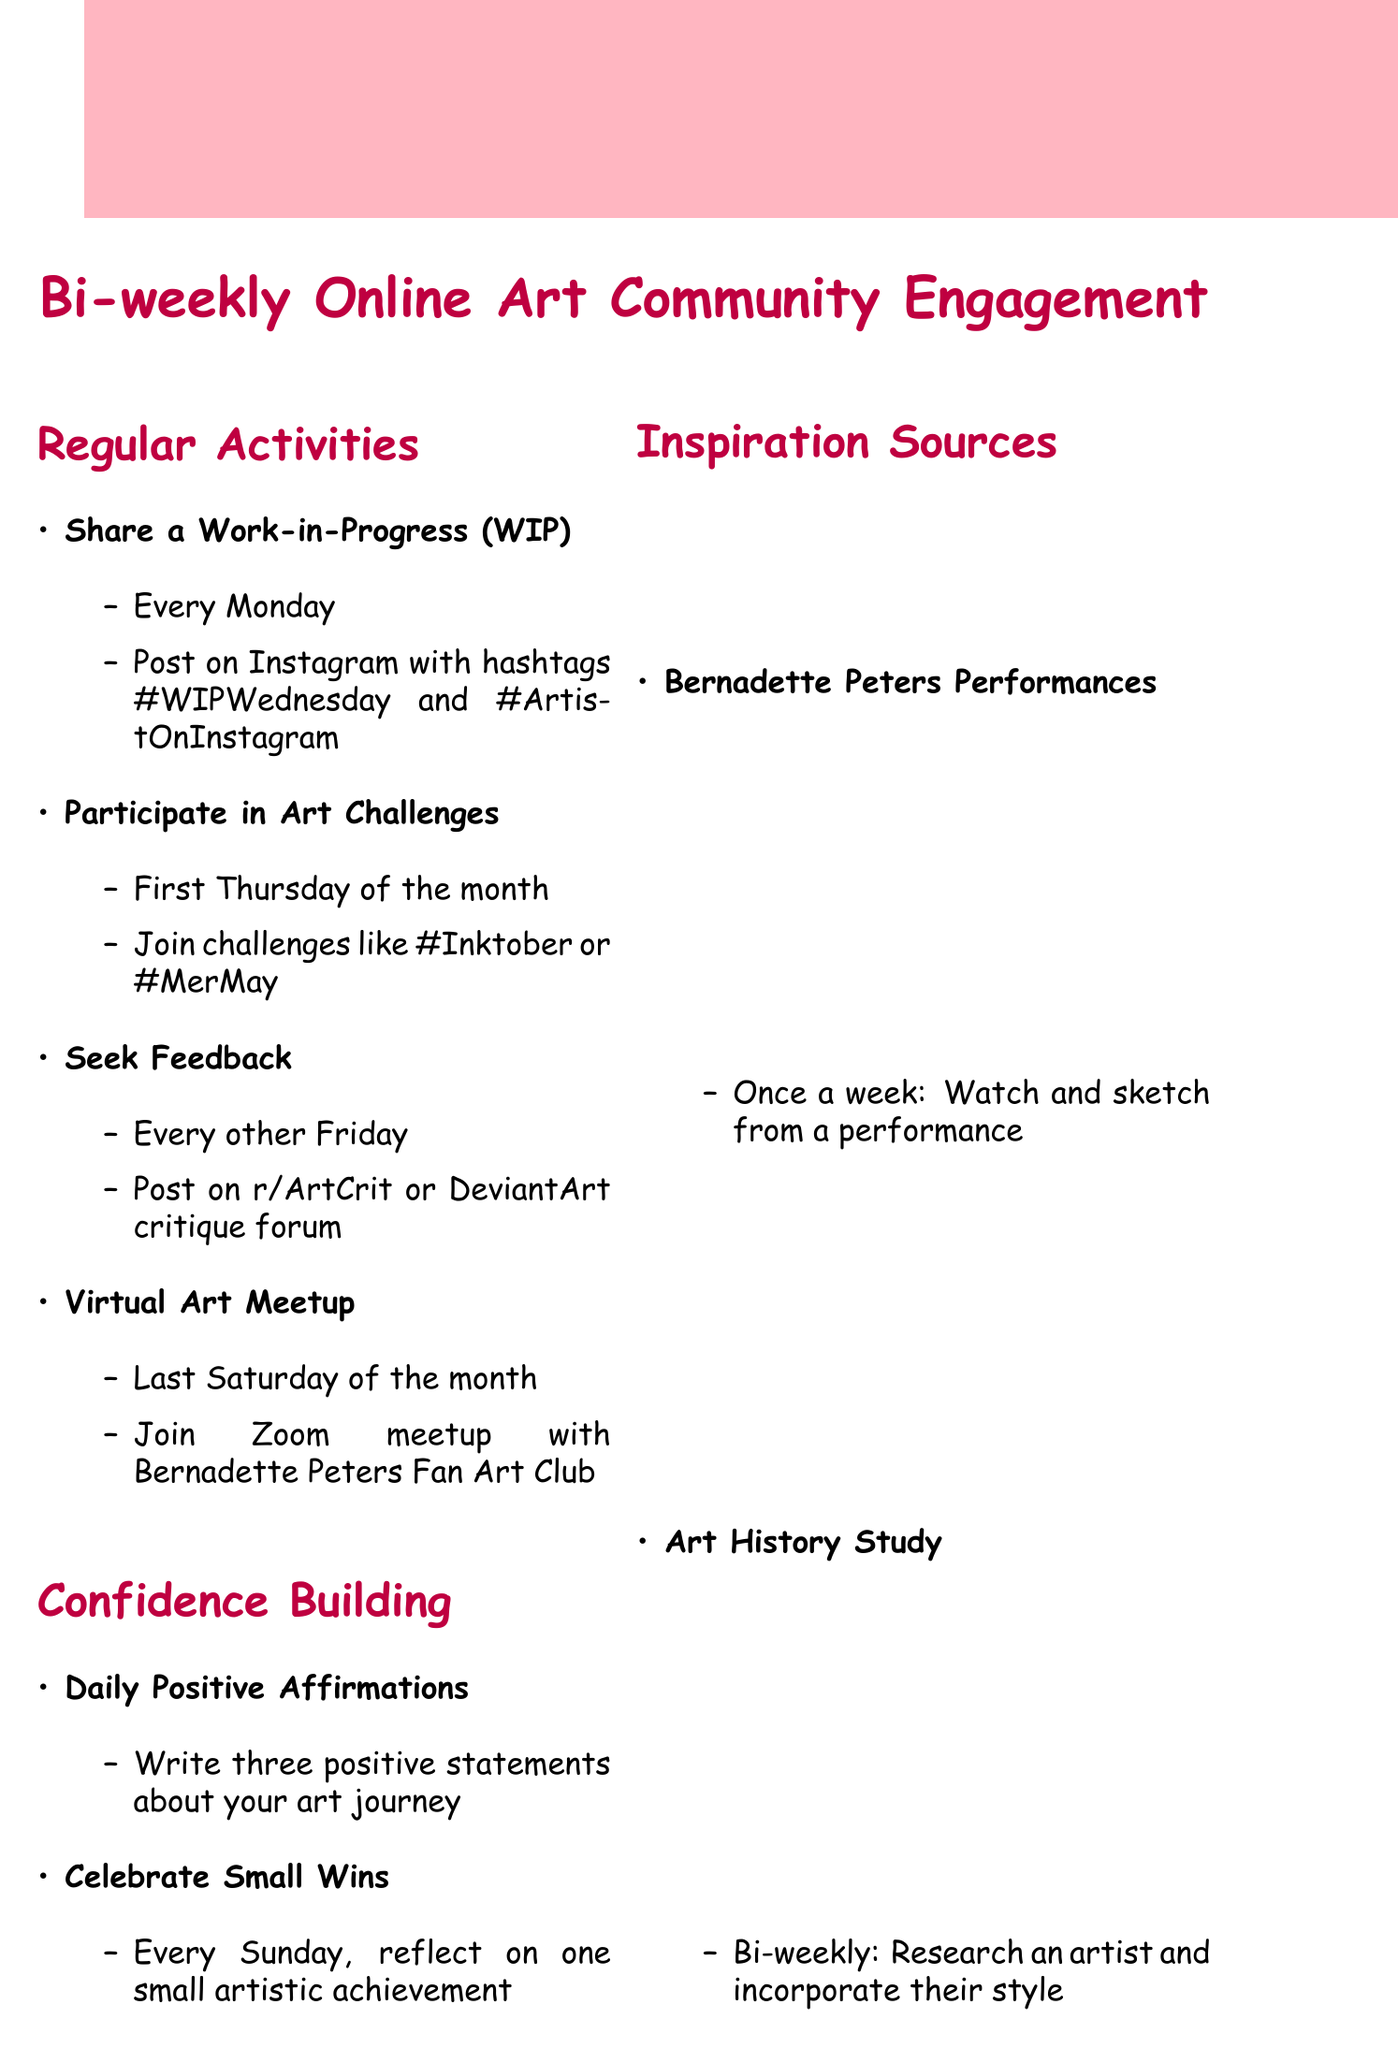What is the primary platform for engagement? The primary platform for engagement listed in the document is Instagram.
Answer: Instagram When do participants share a Work-in-Progress? Participants are instructed to share a Work-in-Progress every Monday.
Answer: Every Monday What is one of the confidence-building exercises? The document mentions Daily Positive Affirmations as a confidence-building exercise.
Answer: Positive Affirmations How often are art challenges participated in? Art challenges are held on the first Thursday of the month.
Answer: First Thursday of the month What do participants reflect on every Sunday? Every Sunday, participants reflect on one small artistic achievement from the past week.
Answer: One small artistic achievement When is the Virtual Art Meetup scheduled? The Virtual Art Meetup occurs on the last Saturday of the month.
Answer: Last Saturday of the month What is a feedback implementation action item? One of the action items after feedback is to create a list of 2-3 actionable improvements.
Answer: 2-3 actionable improvements How often should community members comment on other artists' work? Members are encouraged to comment on other artists' work daily.
Answer: Daily What is suggested to do once a week for inspiration? The document suggests watching and sketching from Bernadette Peters performances once a week.
Answer: Once a week 